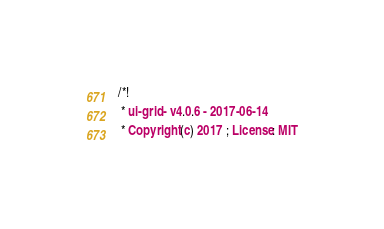Convert code to text. <code><loc_0><loc_0><loc_500><loc_500><_CSS_>/*!
 * ui-grid - v4.0.6 - 2017-06-14
 * Copyright (c) 2017 ; License: MIT</code> 